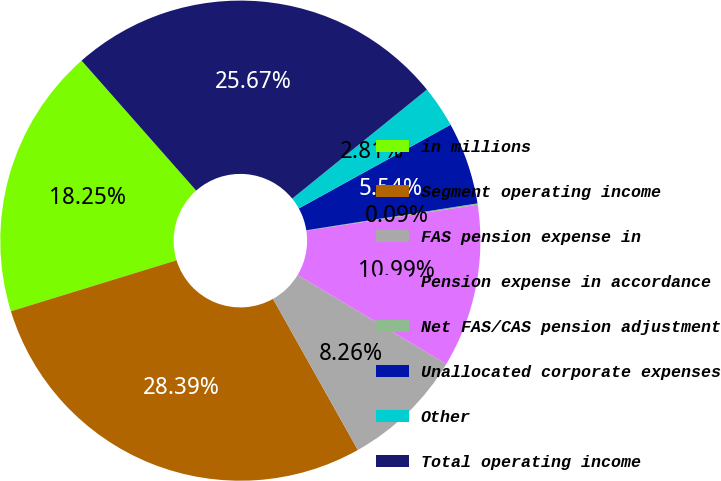Convert chart to OTSL. <chart><loc_0><loc_0><loc_500><loc_500><pie_chart><fcel>in millions<fcel>Segment operating income<fcel>FAS pension expense in<fcel>Pension expense in accordance<fcel>Net FAS/CAS pension adjustment<fcel>Unallocated corporate expenses<fcel>Other<fcel>Total operating income<nl><fcel>18.25%<fcel>28.39%<fcel>8.26%<fcel>10.99%<fcel>0.09%<fcel>5.54%<fcel>2.81%<fcel>25.67%<nl></chart> 